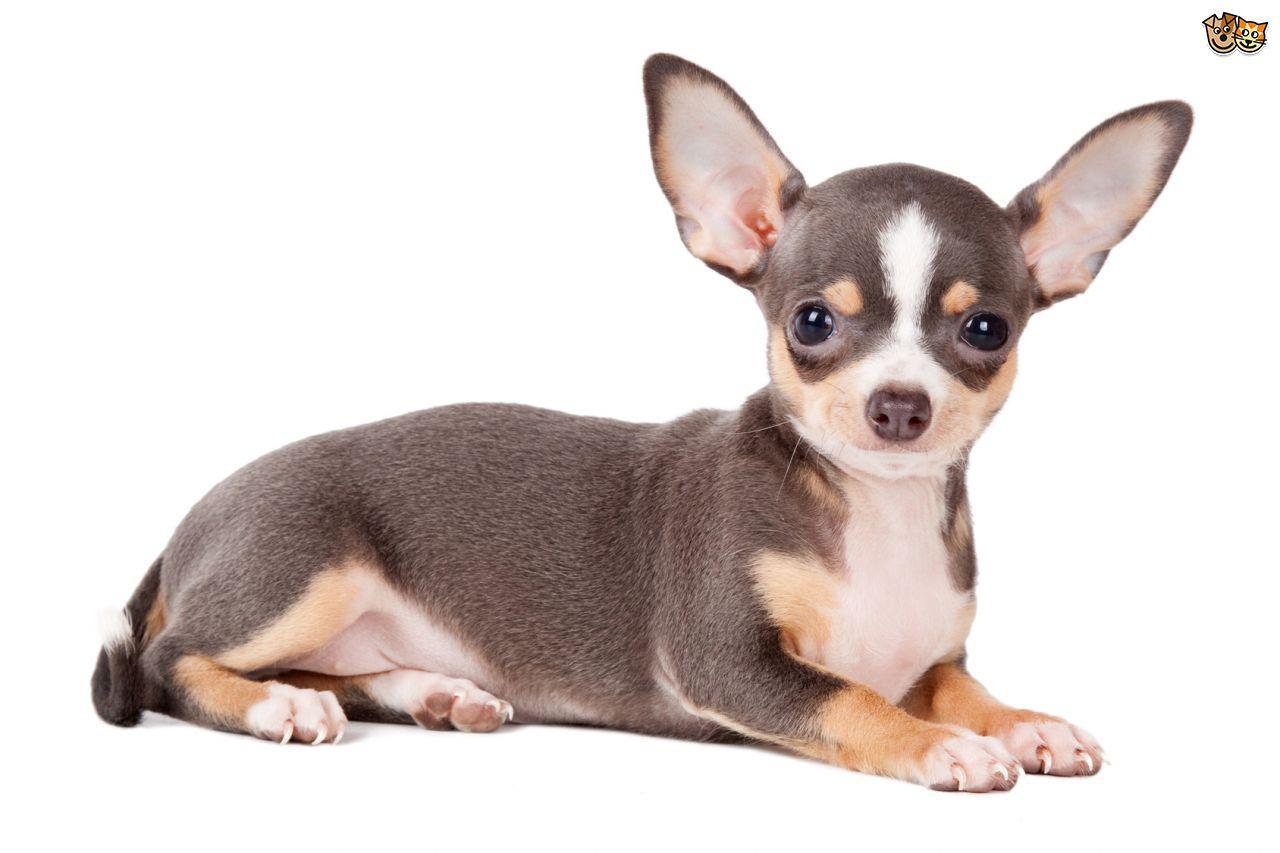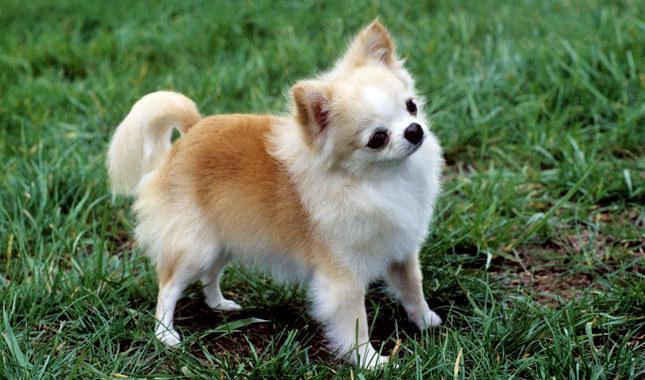The first image is the image on the left, the second image is the image on the right. Examine the images to the left and right. Is the description "There is a chihuahua on grass facing to the right and also a chihua with a darker colouring." accurate? Answer yes or no. Yes. 